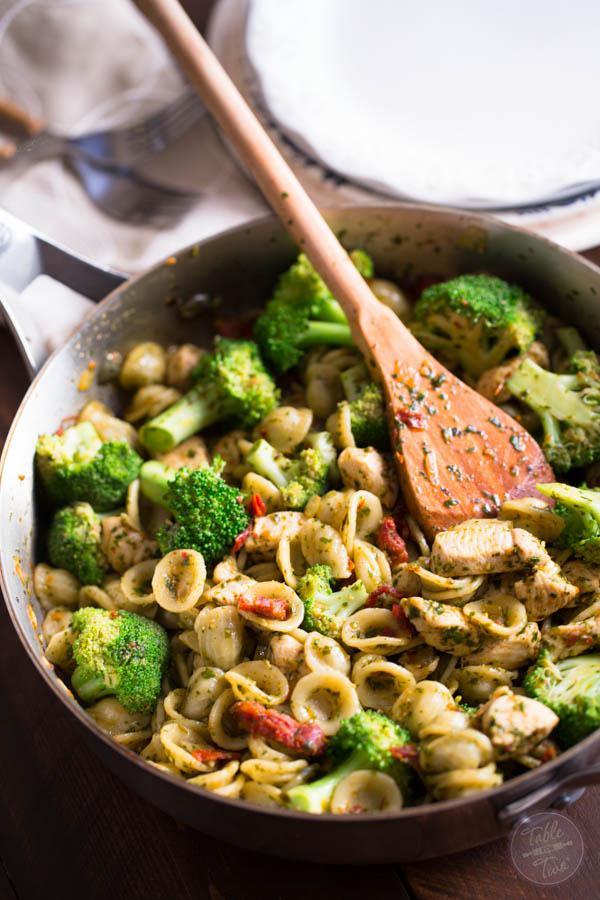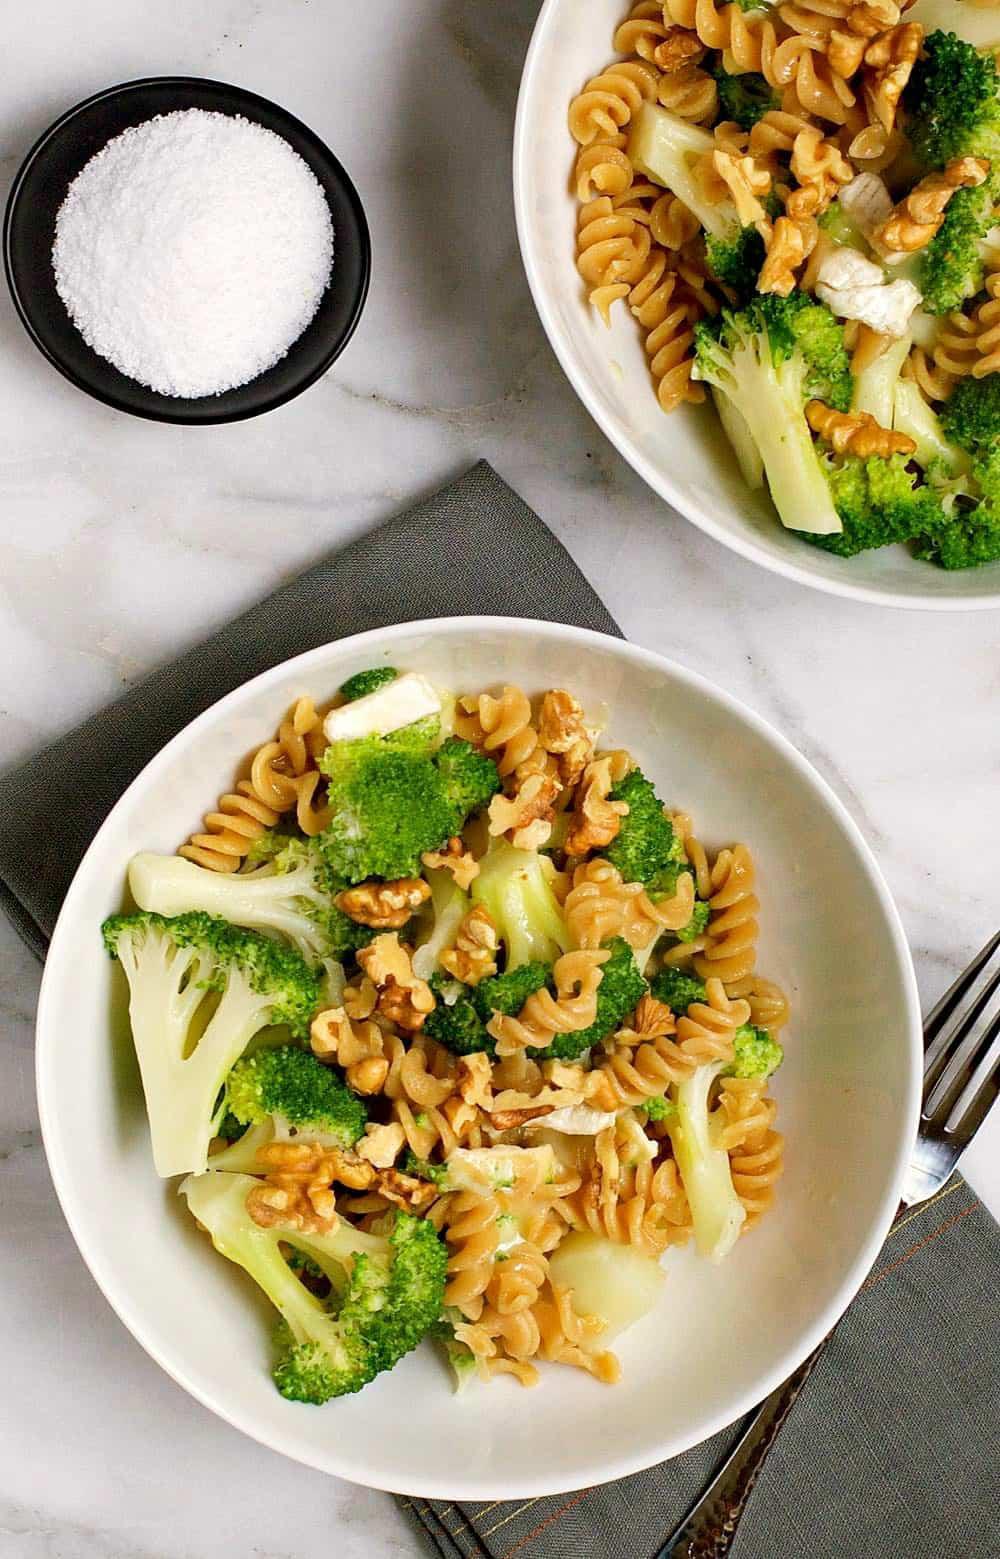The first image is the image on the left, the second image is the image on the right. For the images displayed, is the sentence "One image shows a casserole with a wooden serving spoon, and the other image is at least one individual serving of casserole in a white bowl." factually correct? Answer yes or no. Yes. The first image is the image on the left, the second image is the image on the right. For the images displayed, is the sentence "A wooden spoon sits in a container of food." factually correct? Answer yes or no. Yes. 